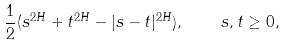<formula> <loc_0><loc_0><loc_500><loc_500>\frac { 1 } { 2 } ( s ^ { 2 H } + t ^ { 2 H } - | s - t | ^ { 2 H } ) , \quad s , t \geq 0 ,</formula> 